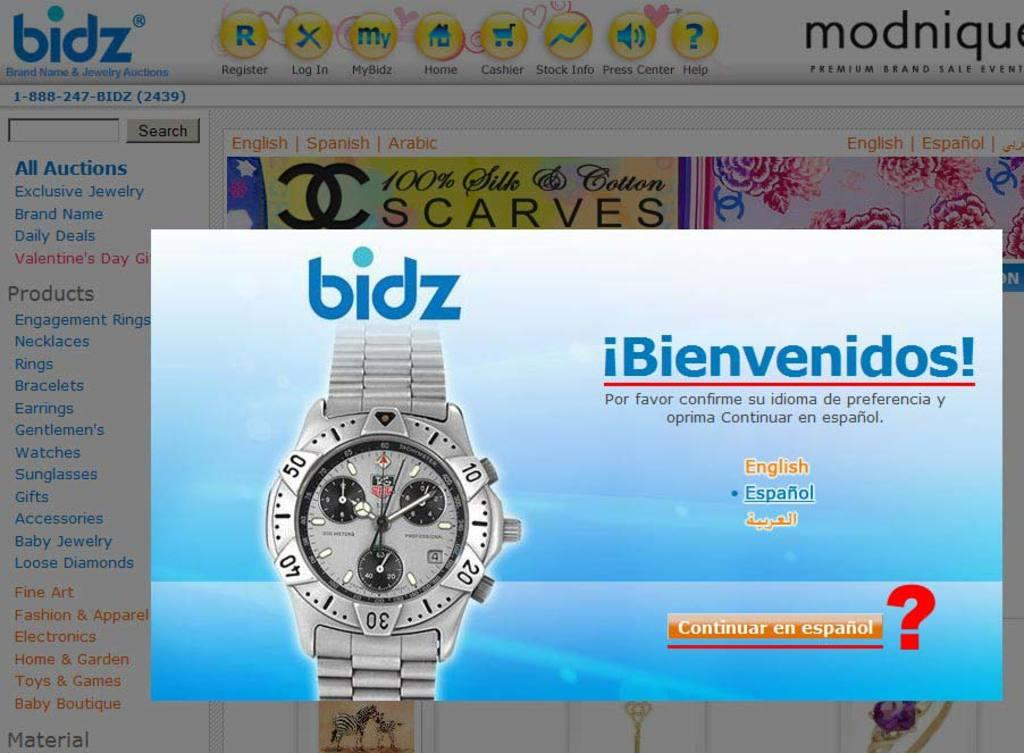<image>
Render a clear and concise summary of the photo. Bidz website is showing a watch on a computer screen. 